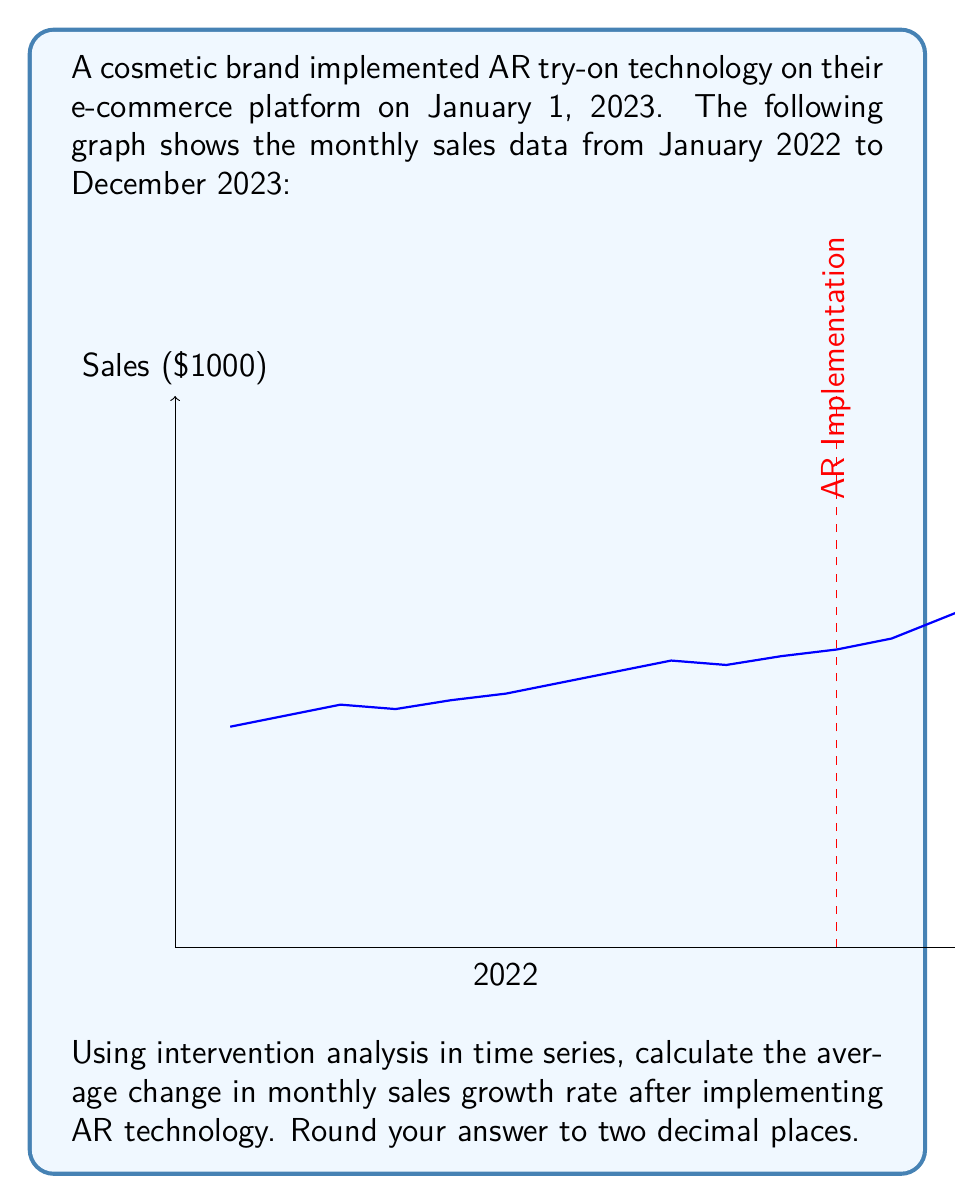Provide a solution to this math problem. To solve this problem, we'll follow these steps:

1) Calculate the average monthly growth rate before and after the intervention.
2) Find the difference between these rates.

Step 1: Calculate average monthly growth rates

a) Before intervention (Jan 2022 - Dec 2022):
Let $S_t$ be the sales at month $t$.
Monthly growth rate = $\frac{S_t - S_{t-1}}{S_{t-1}}$

Growth rates for each month:
Feb: $(105-100)/100 = 0.05$
Mar: $(110-105)/105 = 0.0476$
...
Dec: $(135-132)/132 = 0.0227$

Average pre-intervention growth rate:
$r_{pre} = \frac{0.05 + 0.0476 + ... + 0.0227}{11} = 0.0306$ or 3.06%

b) After intervention (Jan 2023 - Dec 2023):
Using the same method:
Jan: $(140-135)/135 = 0.0370$
Feb: $(150-140)/140 = 0.0714$
...
Dec: $(235-225)/225 = 0.0444$

Average post-intervention growth rate:
$r_{post} = \frac{0.0370 + 0.0714 + ... + 0.0444}{11} = 0.0558$ or 5.58%

Step 2: Calculate the difference

Change in growth rate = $r_{post} - r_{pre}$
$= 0.0558 - 0.0306 = 0.0252$ or 2.52%

Therefore, the average change in monthly sales growth rate after implementing AR technology is 2.52%.
Answer: 2.52% 